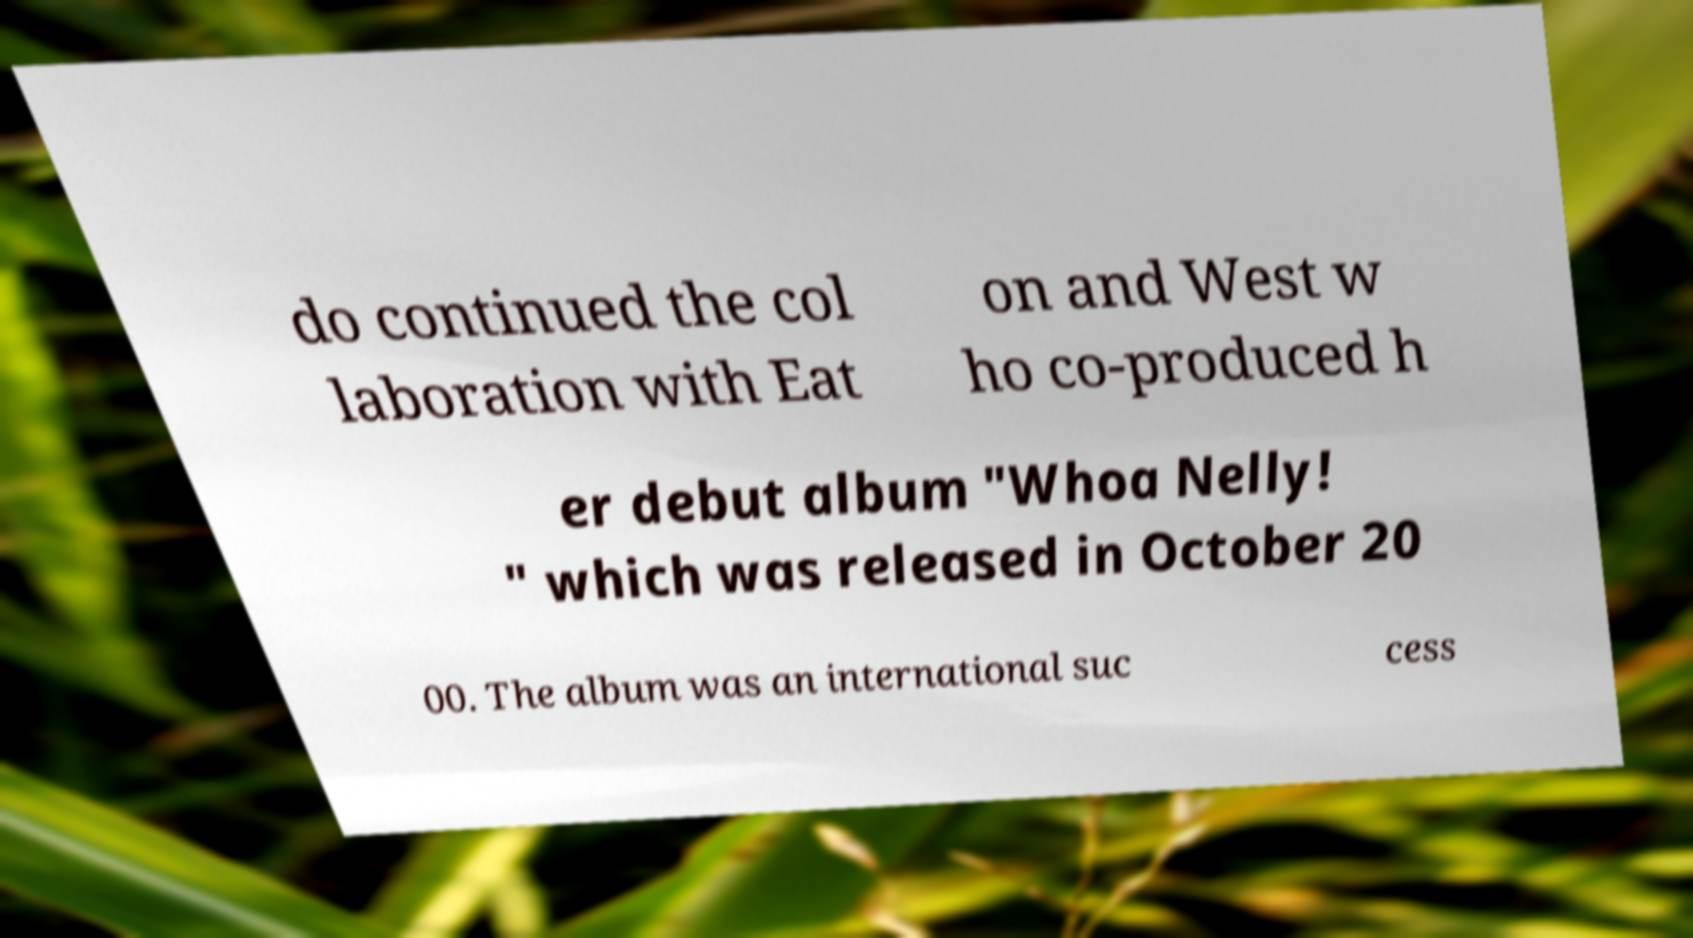I need the written content from this picture converted into text. Can you do that? do continued the col laboration with Eat on and West w ho co-produced h er debut album "Whoa Nelly! " which was released in October 20 00. The album was an international suc cess 